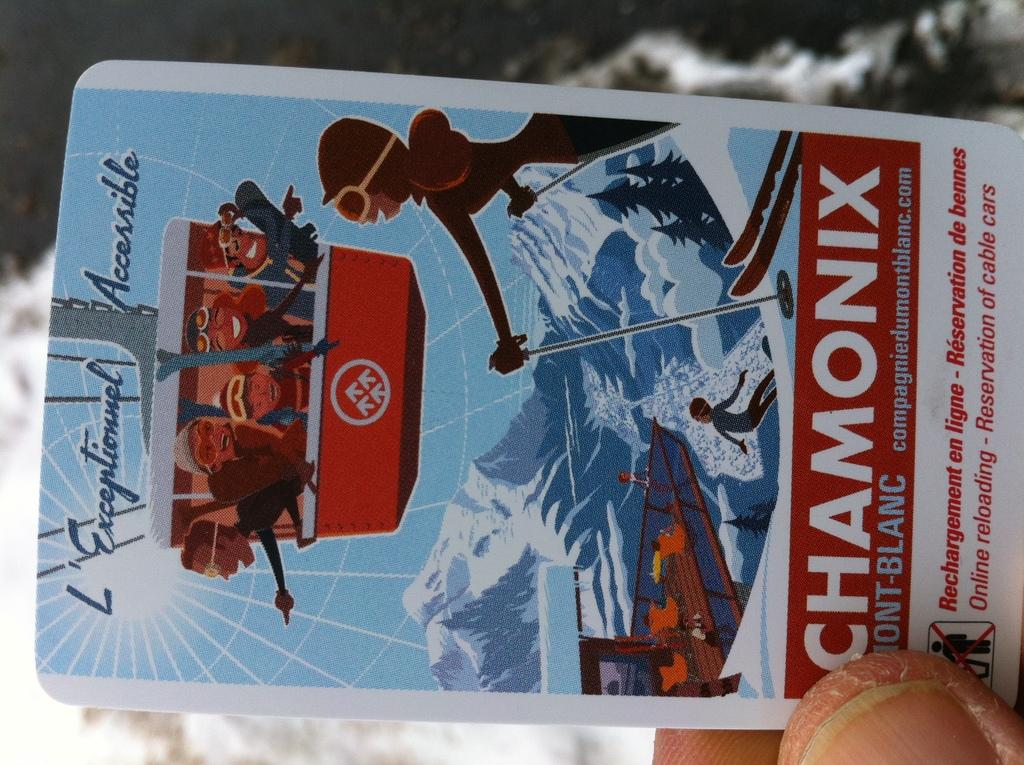What is the person in the image holding? The person is holding a card in the image. Can you describe the card? The card has colorful elements and text written on it. What can be seen in the background of the image? There are many trees and a blurry sky visible in the background of the image. What type of poison is being used in the image? There is no poison present in the image; it features a person holding a card with colorful elements and text. Can you describe the crime scene depicted in the image? There is no crime scene depicted in the image; it shows a person holding a card with colorful elements and text against a background of trees and a blurry sky. 